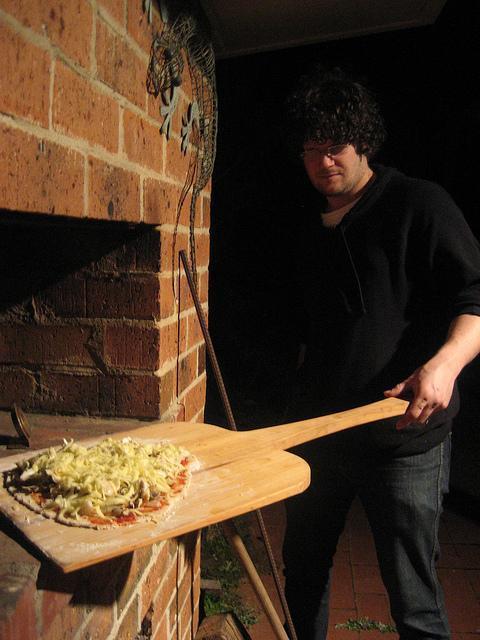How many pizzas are in the picture?
Give a very brief answer. 1. How many trains are to the left of the doors?
Give a very brief answer. 0. 